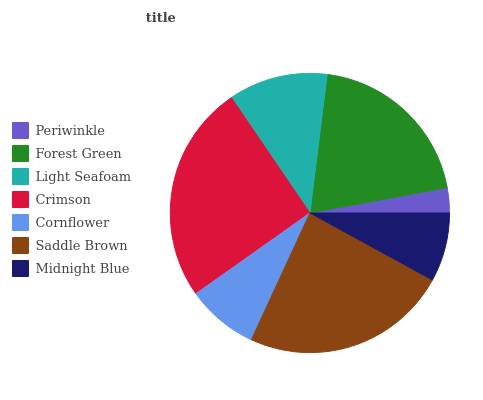Is Periwinkle the minimum?
Answer yes or no. Yes. Is Crimson the maximum?
Answer yes or no. Yes. Is Forest Green the minimum?
Answer yes or no. No. Is Forest Green the maximum?
Answer yes or no. No. Is Forest Green greater than Periwinkle?
Answer yes or no. Yes. Is Periwinkle less than Forest Green?
Answer yes or no. Yes. Is Periwinkle greater than Forest Green?
Answer yes or no. No. Is Forest Green less than Periwinkle?
Answer yes or no. No. Is Light Seafoam the high median?
Answer yes or no. Yes. Is Light Seafoam the low median?
Answer yes or no. Yes. Is Cornflower the high median?
Answer yes or no. No. Is Midnight Blue the low median?
Answer yes or no. No. 